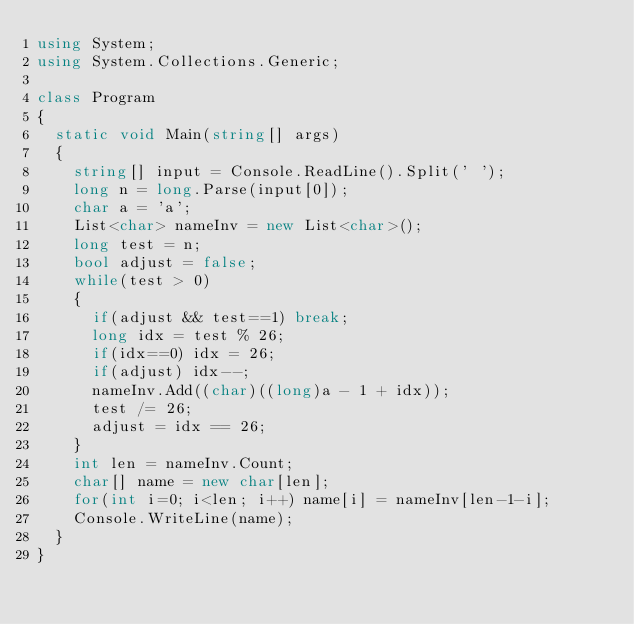<code> <loc_0><loc_0><loc_500><loc_500><_C#_>using System;
using System.Collections.Generic;

class Program
{
	static void Main(string[] args)
	{
		string[] input = Console.ReadLine().Split(' ');
		long n = long.Parse(input[0]);
		char a = 'a';
		List<char> nameInv = new List<char>();
		long test = n;
		bool adjust = false;
		while(test > 0)
		{
			if(adjust && test==1) break;
			long idx = test % 26;
			if(idx==0) idx = 26;
			if(adjust) idx--;
			nameInv.Add((char)((long)a - 1 + idx));
			test /= 26;
			adjust = idx == 26;
		}
		int len = nameInv.Count;
		char[] name = new char[len];
		for(int i=0; i<len; i++) name[i] = nameInv[len-1-i];
		Console.WriteLine(name);
	}
}
</code> 